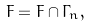Convert formula to latex. <formula><loc_0><loc_0><loc_500><loc_500>F = F \cap \Gamma _ { n } ,</formula> 